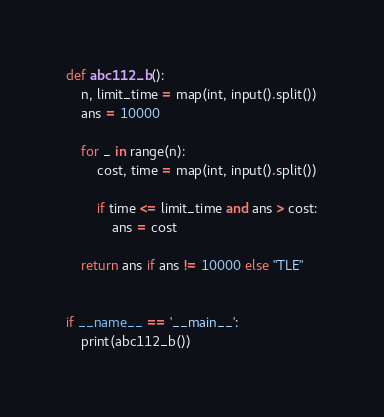<code> <loc_0><loc_0><loc_500><loc_500><_Python_>def abc112_b():
    n, limit_time = map(int, input().split())
    ans = 10000

    for _ in range(n):
        cost, time = map(int, input().split())

        if time <= limit_time and ans > cost:
            ans = cost

    return ans if ans != 10000 else "TLE"


if __name__ == '__main__':
    print(abc112_b())</code> 